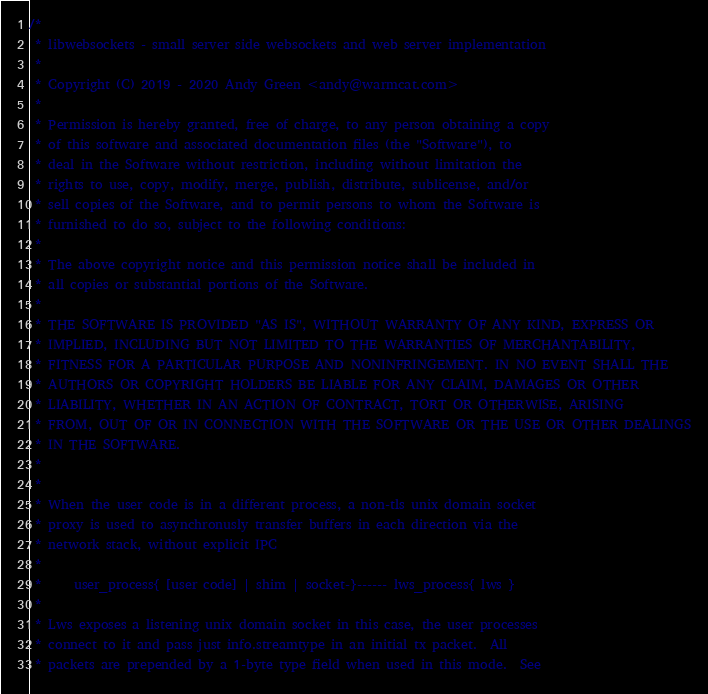<code> <loc_0><loc_0><loc_500><loc_500><_C_>/*
 * libwebsockets - small server side websockets and web server implementation
 *
 * Copyright (C) 2019 - 2020 Andy Green <andy@warmcat.com>
 *
 * Permission is hereby granted, free of charge, to any person obtaining a copy
 * of this software and associated documentation files (the "Software"), to
 * deal in the Software without restriction, including without limitation the
 * rights to use, copy, modify, merge, publish, distribute, sublicense, and/or
 * sell copies of the Software, and to permit persons to whom the Software is
 * furnished to do so, subject to the following conditions:
 *
 * The above copyright notice and this permission notice shall be included in
 * all copies or substantial portions of the Software.
 *
 * THE SOFTWARE IS PROVIDED "AS IS", WITHOUT WARRANTY OF ANY KIND, EXPRESS OR
 * IMPLIED, INCLUDING BUT NOT LIMITED TO THE WARRANTIES OF MERCHANTABILITY,
 * FITNESS FOR A PARTICULAR PURPOSE AND NONINFRINGEMENT. IN NO EVENT SHALL THE
 * AUTHORS OR COPYRIGHT HOLDERS BE LIABLE FOR ANY CLAIM, DAMAGES OR OTHER
 * LIABILITY, WHETHER IN AN ACTION OF CONTRACT, TORT OR OTHERWISE, ARISING
 * FROM, OUT OF OR IN CONNECTION WITH THE SOFTWARE OR THE USE OR OTHER DEALINGS
 * IN THE SOFTWARE.
 *
 *
 * When the user code is in a different process, a non-tls unix domain socket
 * proxy is used to asynchronusly transfer buffers in each direction via the
 * network stack, without explicit IPC
 *
 *     user_process{ [user code] | shim | socket-}------ lws_process{ lws }
 *
 * Lws exposes a listening unix domain socket in this case, the user processes
 * connect to it and pass just info.streamtype in an initial tx packet.  All
 * packets are prepended by a 1-byte type field when used in this mode.  See</code> 